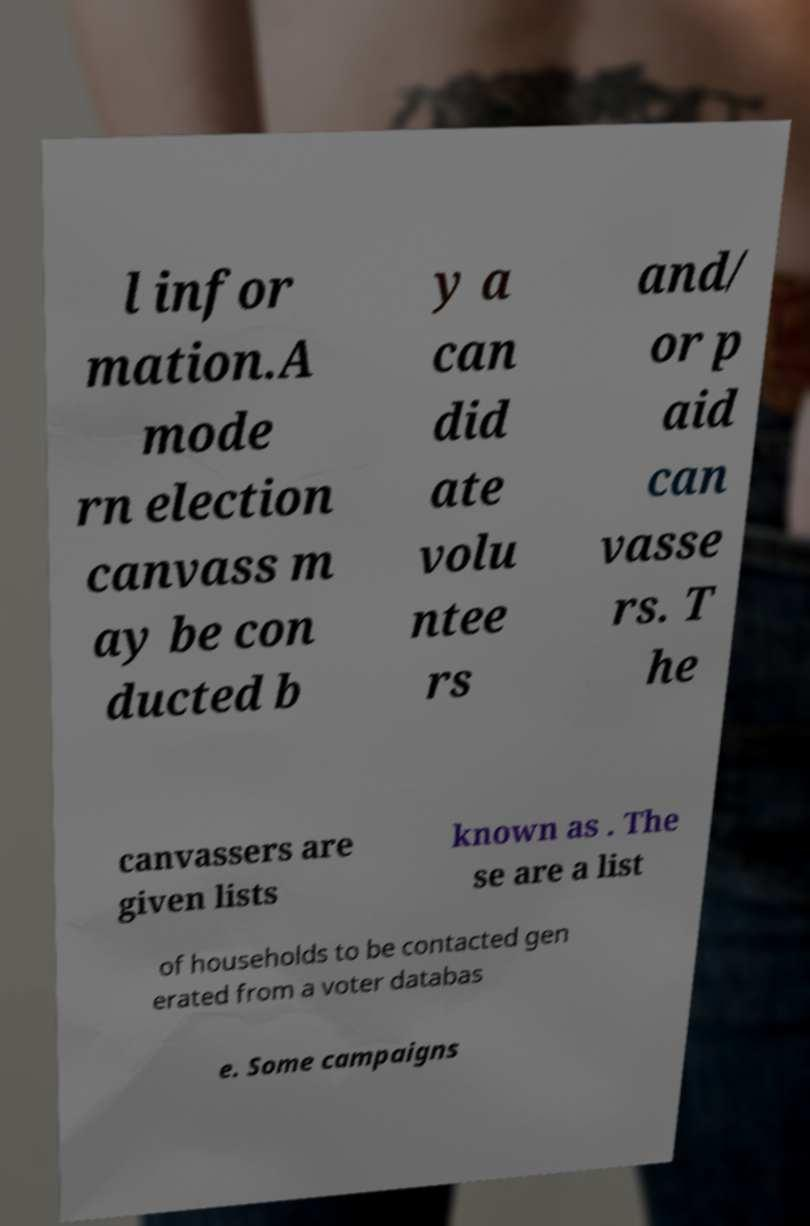Can you read and provide the text displayed in the image?This photo seems to have some interesting text. Can you extract and type it out for me? l infor mation.A mode rn election canvass m ay be con ducted b y a can did ate volu ntee rs and/ or p aid can vasse rs. T he canvassers are given lists known as . The se are a list of households to be contacted gen erated from a voter databas e. Some campaigns 